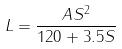<formula> <loc_0><loc_0><loc_500><loc_500>L = \frac { A S ^ { 2 } } { 1 2 0 + 3 . 5 S }</formula> 